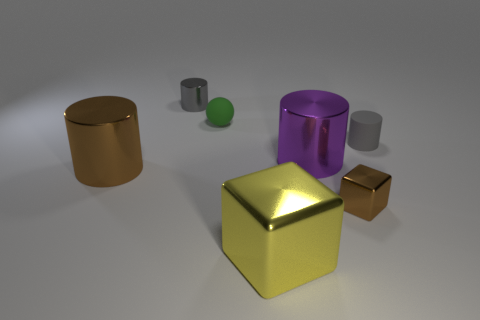Is the tiny metallic cylinder the same color as the rubber cylinder?
Provide a short and direct response. Yes. There is a gray thing that is the same size as the gray metallic cylinder; what material is it?
Offer a terse response. Rubber. How big is the metal thing that is left of the tiny green ball and in front of the small matte ball?
Ensure brevity in your answer.  Large. The cylinder that is both right of the small shiny cylinder and on the left side of the small matte cylinder is what color?
Offer a very short reply. Purple. Are there fewer big metallic blocks that are to the right of the large purple thing than big things that are behind the tiny brown shiny block?
Keep it short and to the point. Yes. What number of other small green objects have the same shape as the green rubber object?
Ensure brevity in your answer.  0. There is a gray object that is made of the same material as the big purple cylinder; what is its size?
Ensure brevity in your answer.  Small. There is a tiny metallic thing on the right side of the metallic object that is behind the matte ball; what is its color?
Your answer should be very brief. Brown. There is a yellow shiny thing; is it the same shape as the brown metal object right of the yellow block?
Provide a short and direct response. Yes. What number of shiny things are the same size as the rubber ball?
Provide a succinct answer. 2. 